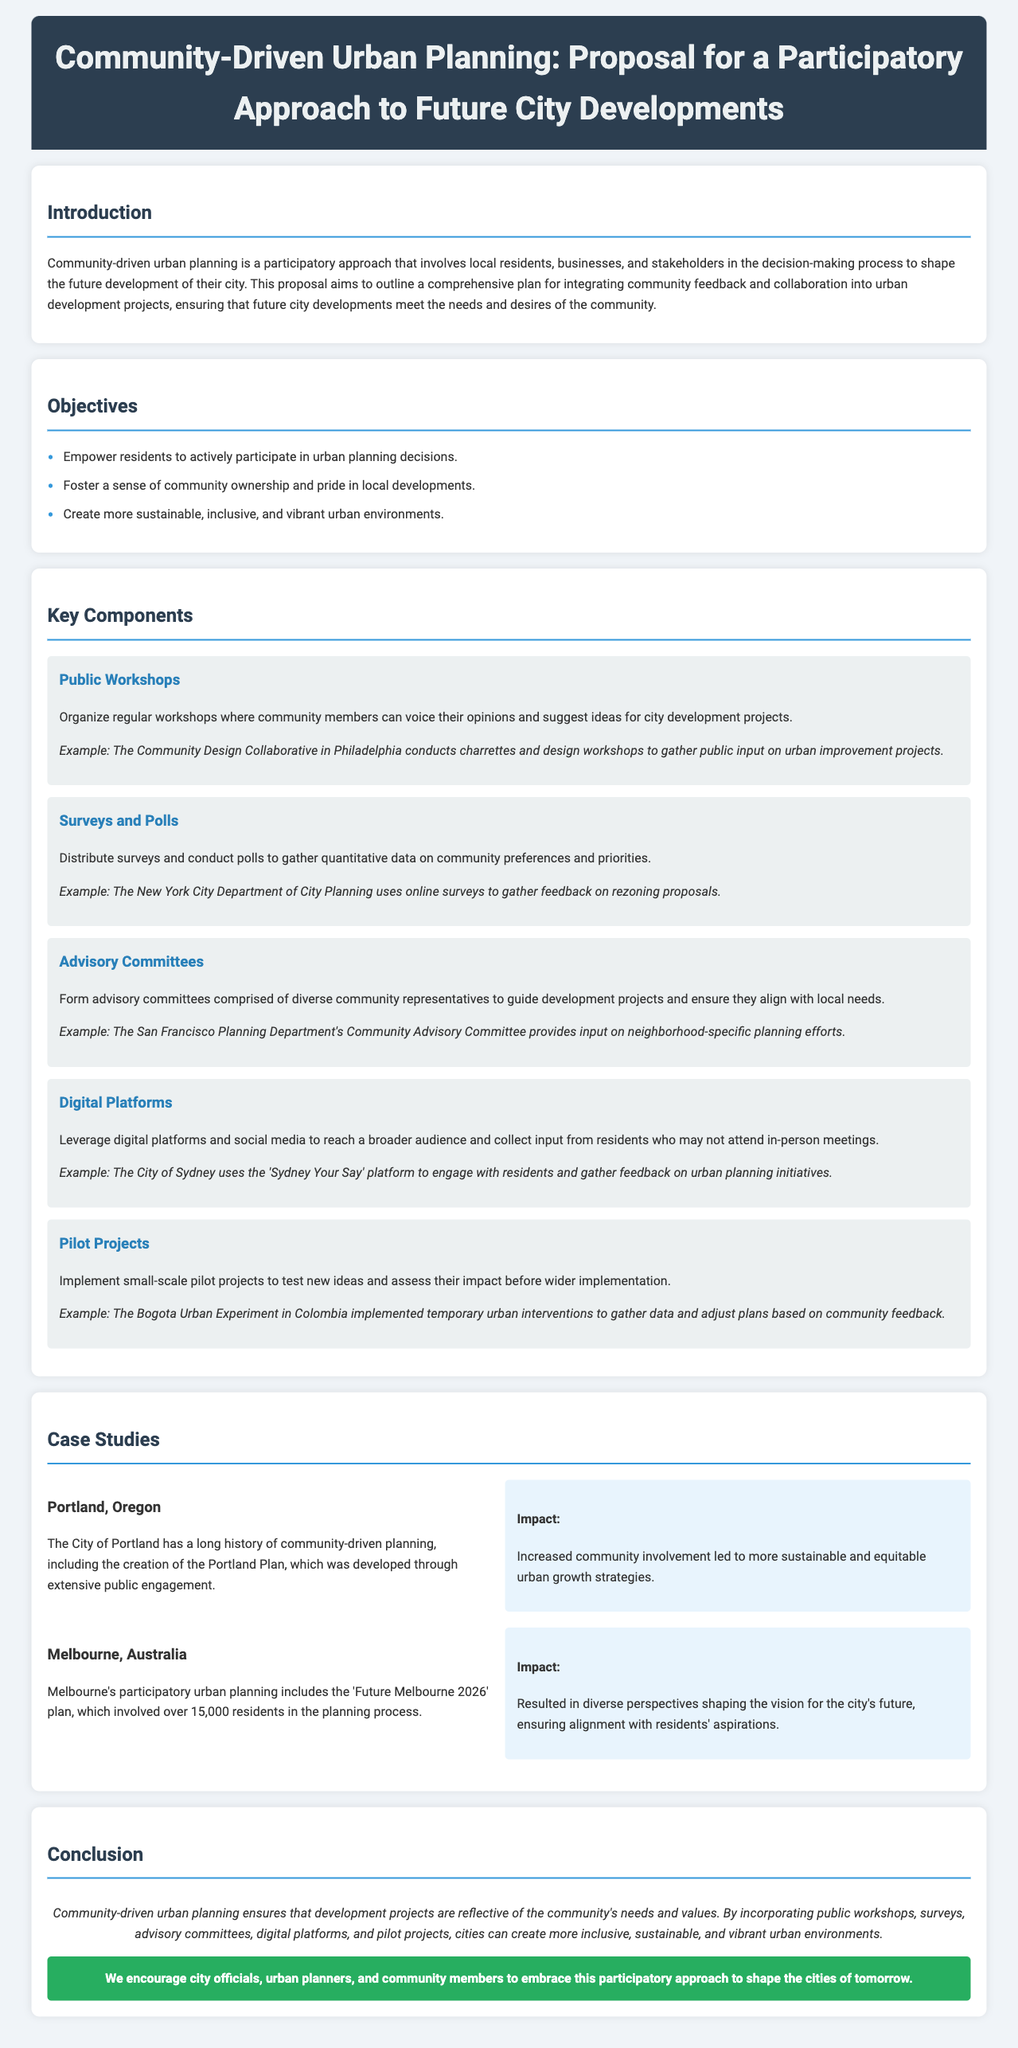what is the title of the proposal? The title of the proposal is located at the top of the document.
Answer: Community-Driven Urban Planning: Proposal for a Participatory Approach to Future City Developments what is one of the main objectives outlined in the proposal? The objectives are listed in a bullet format under the objectives section.
Answer: Empower residents to actively participate in urban planning decisions which city is mentioned as a case study that has a long history of community-driven planning? The case studies include specific cities as examples of community-driven planning.
Answer: Portland, Oregon what method is suggested for gathering quantitative data on community preferences? The key components section describes various methods for community engagement, one being surveys.
Answer: Surveys and Polls how many residents were involved in Melbourne's 'Future Melbourne 2026' plan? The number of residents involved is mentioned in the case study about Melbourne.
Answer: Over 15,000 residents what is a key component of the community-driven urban planning approach? Key components are identified throughout the proposal, such as public workshops.
Answer: Public Workshops what is considered a potential impact of increased community involvement according to the case study on Portland? The impact is noted in the paragraph following the case study.
Answer: More sustainable and equitable urban growth strategies what digital platform does the City of Sydney use to engage with residents? This is specifically stated in the key components section under Digital Platforms.
Answer: Sydney Your Say 